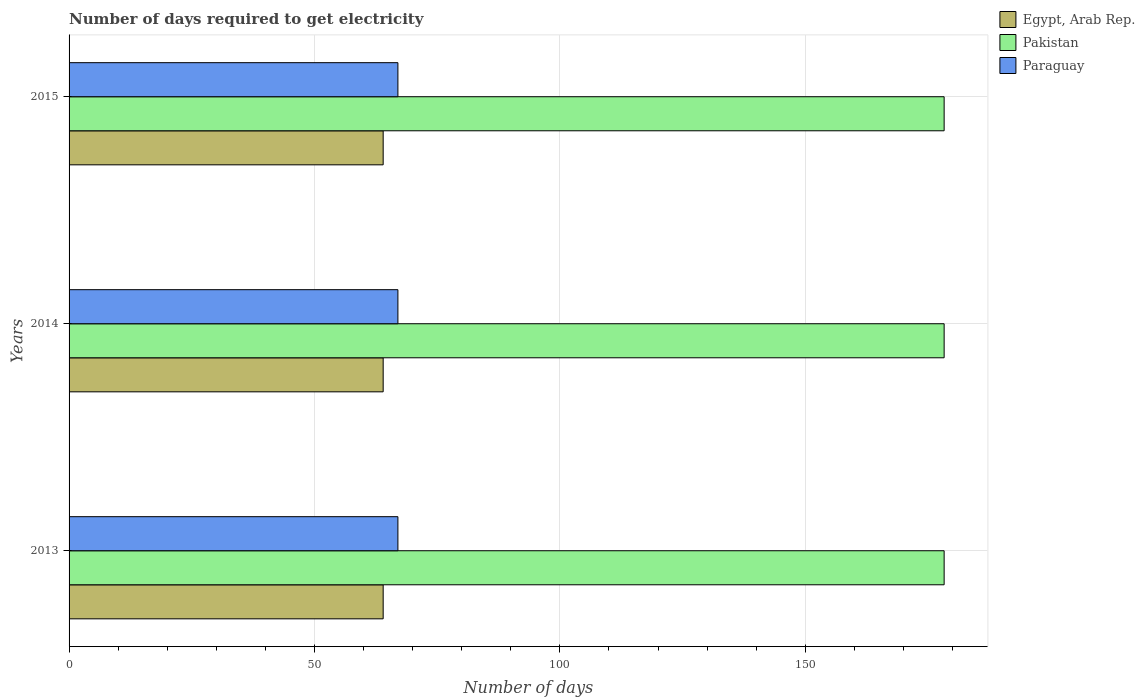How many different coloured bars are there?
Provide a succinct answer. 3. Are the number of bars per tick equal to the number of legend labels?
Provide a succinct answer. Yes. How many bars are there on the 1st tick from the bottom?
Offer a terse response. 3. What is the label of the 1st group of bars from the top?
Give a very brief answer. 2015. In how many cases, is the number of bars for a given year not equal to the number of legend labels?
Your response must be concise. 0. What is the number of days required to get electricity in in Paraguay in 2015?
Make the answer very short. 67. Across all years, what is the maximum number of days required to get electricity in in Paraguay?
Ensure brevity in your answer.  67. Across all years, what is the minimum number of days required to get electricity in in Paraguay?
Keep it short and to the point. 67. In which year was the number of days required to get electricity in in Egypt, Arab Rep. maximum?
Offer a terse response. 2013. What is the total number of days required to get electricity in in Pakistan in the graph?
Your response must be concise. 534.9. What is the difference between the number of days required to get electricity in in Pakistan in 2014 and the number of days required to get electricity in in Paraguay in 2013?
Provide a succinct answer. 111.3. What is the average number of days required to get electricity in in Pakistan per year?
Offer a terse response. 178.3. In the year 2014, what is the difference between the number of days required to get electricity in in Pakistan and number of days required to get electricity in in Egypt, Arab Rep.?
Make the answer very short. 114.3. What is the ratio of the number of days required to get electricity in in Paraguay in 2013 to that in 2014?
Your answer should be very brief. 1. Is the difference between the number of days required to get electricity in in Pakistan in 2013 and 2015 greater than the difference between the number of days required to get electricity in in Egypt, Arab Rep. in 2013 and 2015?
Give a very brief answer. No. What is the difference between the highest and the lowest number of days required to get electricity in in Pakistan?
Ensure brevity in your answer.  0. What does the 1st bar from the bottom in 2015 represents?
Your answer should be compact. Egypt, Arab Rep. How many bars are there?
Provide a short and direct response. 9. Are all the bars in the graph horizontal?
Offer a very short reply. Yes. What is the difference between two consecutive major ticks on the X-axis?
Your answer should be very brief. 50. Does the graph contain any zero values?
Offer a very short reply. No. Does the graph contain grids?
Your response must be concise. Yes. Where does the legend appear in the graph?
Give a very brief answer. Top right. How are the legend labels stacked?
Ensure brevity in your answer.  Vertical. What is the title of the graph?
Keep it short and to the point. Number of days required to get electricity. Does "Turkey" appear as one of the legend labels in the graph?
Ensure brevity in your answer.  No. What is the label or title of the X-axis?
Make the answer very short. Number of days. What is the Number of days of Pakistan in 2013?
Provide a short and direct response. 178.3. What is the Number of days in Paraguay in 2013?
Provide a succinct answer. 67. What is the Number of days of Egypt, Arab Rep. in 2014?
Offer a terse response. 64. What is the Number of days in Pakistan in 2014?
Your answer should be very brief. 178.3. What is the Number of days in Egypt, Arab Rep. in 2015?
Provide a succinct answer. 64. What is the Number of days in Pakistan in 2015?
Provide a short and direct response. 178.3. What is the Number of days of Paraguay in 2015?
Your answer should be very brief. 67. Across all years, what is the maximum Number of days of Egypt, Arab Rep.?
Make the answer very short. 64. Across all years, what is the maximum Number of days in Pakistan?
Keep it short and to the point. 178.3. Across all years, what is the minimum Number of days in Egypt, Arab Rep.?
Offer a terse response. 64. Across all years, what is the minimum Number of days of Pakistan?
Your answer should be compact. 178.3. What is the total Number of days of Egypt, Arab Rep. in the graph?
Your response must be concise. 192. What is the total Number of days of Pakistan in the graph?
Provide a succinct answer. 534.9. What is the total Number of days of Paraguay in the graph?
Your answer should be very brief. 201. What is the difference between the Number of days in Egypt, Arab Rep. in 2013 and that in 2014?
Your answer should be very brief. 0. What is the difference between the Number of days in Pakistan in 2013 and that in 2014?
Make the answer very short. 0. What is the difference between the Number of days in Paraguay in 2013 and that in 2014?
Provide a succinct answer. 0. What is the difference between the Number of days of Egypt, Arab Rep. in 2013 and that in 2015?
Offer a terse response. 0. What is the difference between the Number of days in Egypt, Arab Rep. in 2013 and the Number of days in Pakistan in 2014?
Your answer should be compact. -114.3. What is the difference between the Number of days of Egypt, Arab Rep. in 2013 and the Number of days of Paraguay in 2014?
Provide a short and direct response. -3. What is the difference between the Number of days in Pakistan in 2013 and the Number of days in Paraguay in 2014?
Provide a short and direct response. 111.3. What is the difference between the Number of days of Egypt, Arab Rep. in 2013 and the Number of days of Pakistan in 2015?
Provide a short and direct response. -114.3. What is the difference between the Number of days of Pakistan in 2013 and the Number of days of Paraguay in 2015?
Keep it short and to the point. 111.3. What is the difference between the Number of days in Egypt, Arab Rep. in 2014 and the Number of days in Pakistan in 2015?
Your response must be concise. -114.3. What is the difference between the Number of days in Pakistan in 2014 and the Number of days in Paraguay in 2015?
Your answer should be very brief. 111.3. What is the average Number of days in Pakistan per year?
Provide a succinct answer. 178.3. What is the average Number of days in Paraguay per year?
Offer a very short reply. 67. In the year 2013, what is the difference between the Number of days in Egypt, Arab Rep. and Number of days in Pakistan?
Provide a succinct answer. -114.3. In the year 2013, what is the difference between the Number of days in Pakistan and Number of days in Paraguay?
Offer a terse response. 111.3. In the year 2014, what is the difference between the Number of days in Egypt, Arab Rep. and Number of days in Pakistan?
Ensure brevity in your answer.  -114.3. In the year 2014, what is the difference between the Number of days of Egypt, Arab Rep. and Number of days of Paraguay?
Your answer should be very brief. -3. In the year 2014, what is the difference between the Number of days in Pakistan and Number of days in Paraguay?
Provide a short and direct response. 111.3. In the year 2015, what is the difference between the Number of days in Egypt, Arab Rep. and Number of days in Pakistan?
Provide a succinct answer. -114.3. In the year 2015, what is the difference between the Number of days in Egypt, Arab Rep. and Number of days in Paraguay?
Make the answer very short. -3. In the year 2015, what is the difference between the Number of days of Pakistan and Number of days of Paraguay?
Your response must be concise. 111.3. What is the ratio of the Number of days of Egypt, Arab Rep. in 2013 to that in 2015?
Keep it short and to the point. 1. What is the ratio of the Number of days in Egypt, Arab Rep. in 2014 to that in 2015?
Provide a succinct answer. 1. What is the difference between the highest and the second highest Number of days of Egypt, Arab Rep.?
Offer a very short reply. 0. What is the difference between the highest and the second highest Number of days in Paraguay?
Your response must be concise. 0. What is the difference between the highest and the lowest Number of days of Egypt, Arab Rep.?
Provide a succinct answer. 0. What is the difference between the highest and the lowest Number of days in Paraguay?
Offer a terse response. 0. 